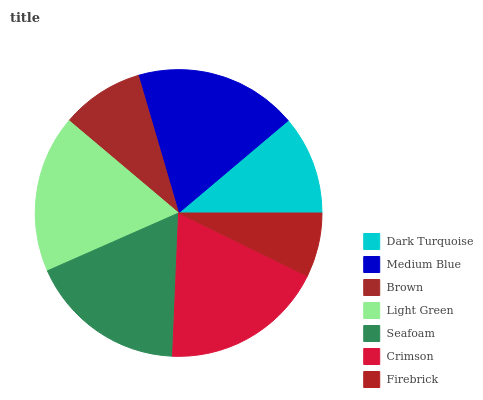Is Firebrick the minimum?
Answer yes or no. Yes. Is Crimson the maximum?
Answer yes or no. Yes. Is Medium Blue the minimum?
Answer yes or no. No. Is Medium Blue the maximum?
Answer yes or no. No. Is Medium Blue greater than Dark Turquoise?
Answer yes or no. Yes. Is Dark Turquoise less than Medium Blue?
Answer yes or no. Yes. Is Dark Turquoise greater than Medium Blue?
Answer yes or no. No. Is Medium Blue less than Dark Turquoise?
Answer yes or no. No. Is Seafoam the high median?
Answer yes or no. Yes. Is Seafoam the low median?
Answer yes or no. Yes. Is Light Green the high median?
Answer yes or no. No. Is Firebrick the low median?
Answer yes or no. No. 